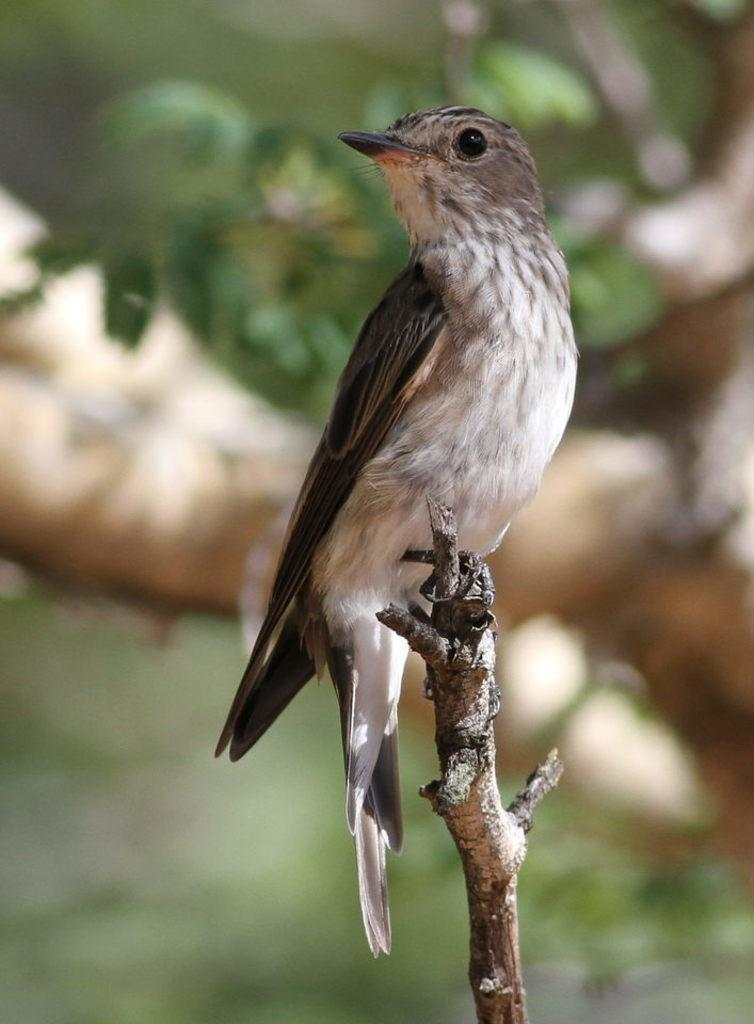What type of animal is present in the image? There is a bird in the image. Where is the bird located in the image? The bird is standing on a stem in the image. What else can be seen in the image besides the bird? Leaves are visible in the image. What type of plastic material is being used for the bird's discussion in the image? There is no discussion or plastic material present in the image; it features a bird standing on a stem with leaves visible. 